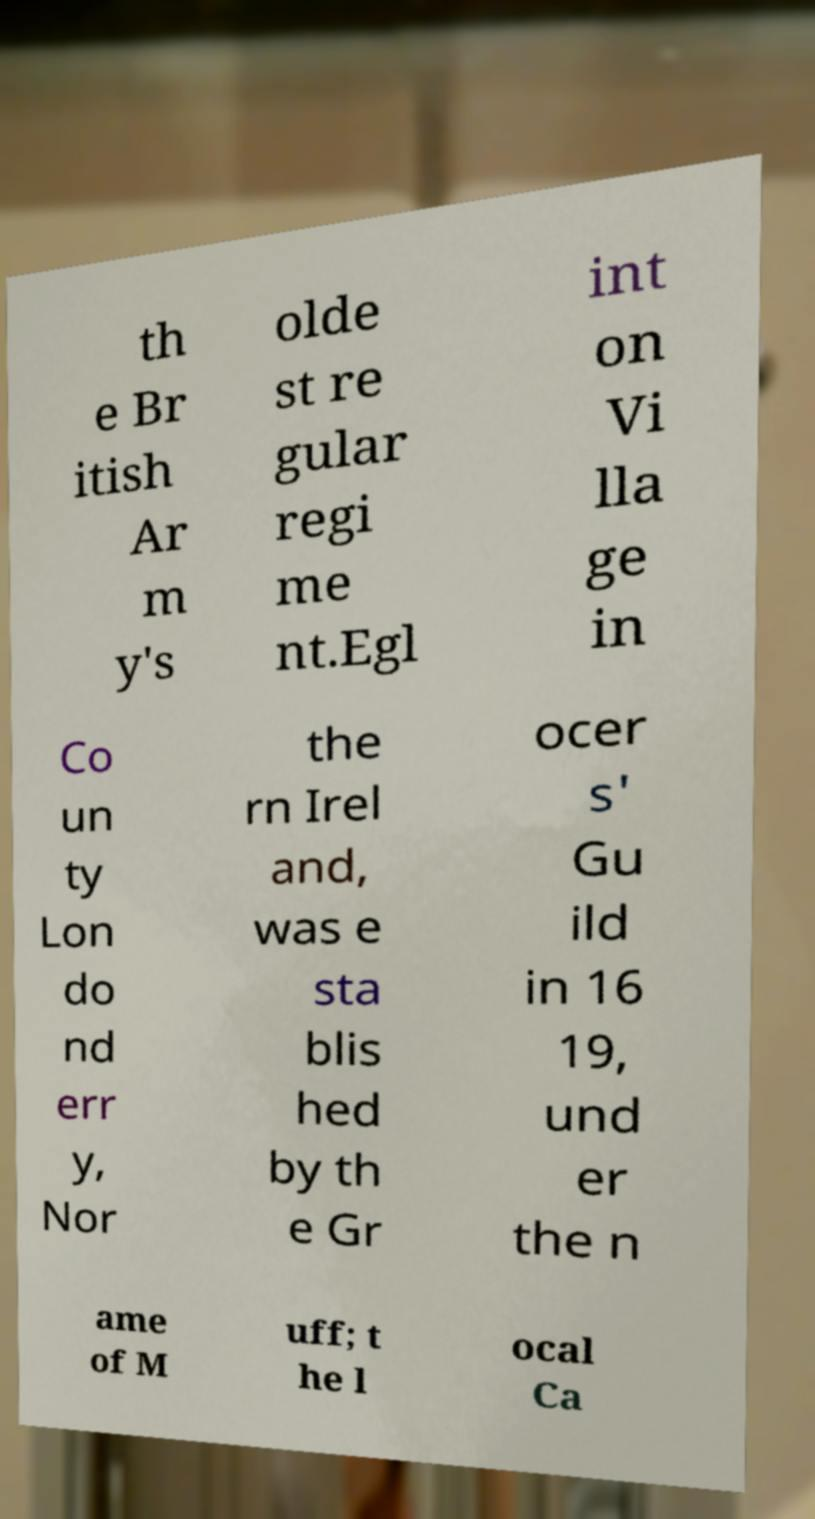I need the written content from this picture converted into text. Can you do that? th e Br itish Ar m y's olde st re gular regi me nt.Egl int on Vi lla ge in Co un ty Lon do nd err y, Nor the rn Irel and, was e sta blis hed by th e Gr ocer s' Gu ild in 16 19, und er the n ame of M uff; t he l ocal Ca 